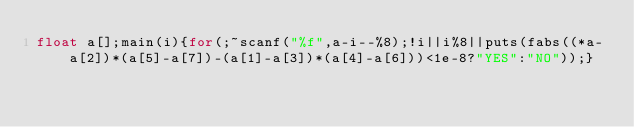<code> <loc_0><loc_0><loc_500><loc_500><_C_>float a[];main(i){for(;~scanf("%f",a-i--%8);!i||i%8||puts(fabs((*a-a[2])*(a[5]-a[7])-(a[1]-a[3])*(a[4]-a[6]))<1e-8?"YES":"NO"));}</code> 